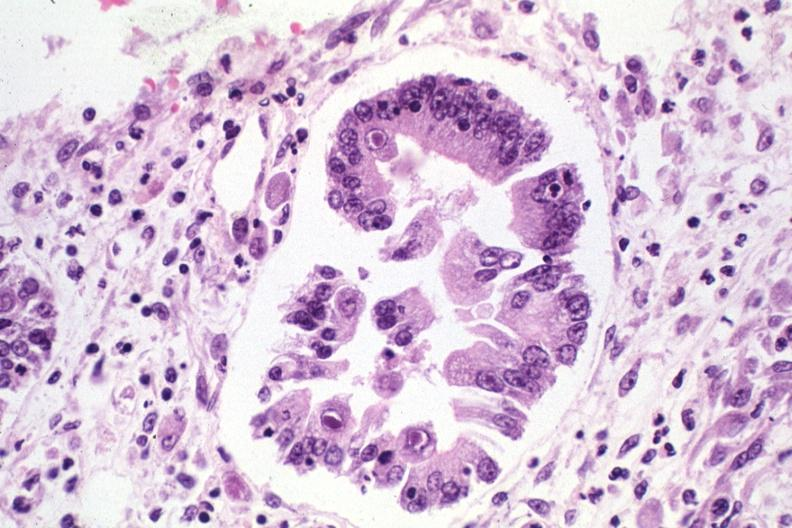what does this image show?
Answer the question using a single word or phrase. Inclusion bodies 